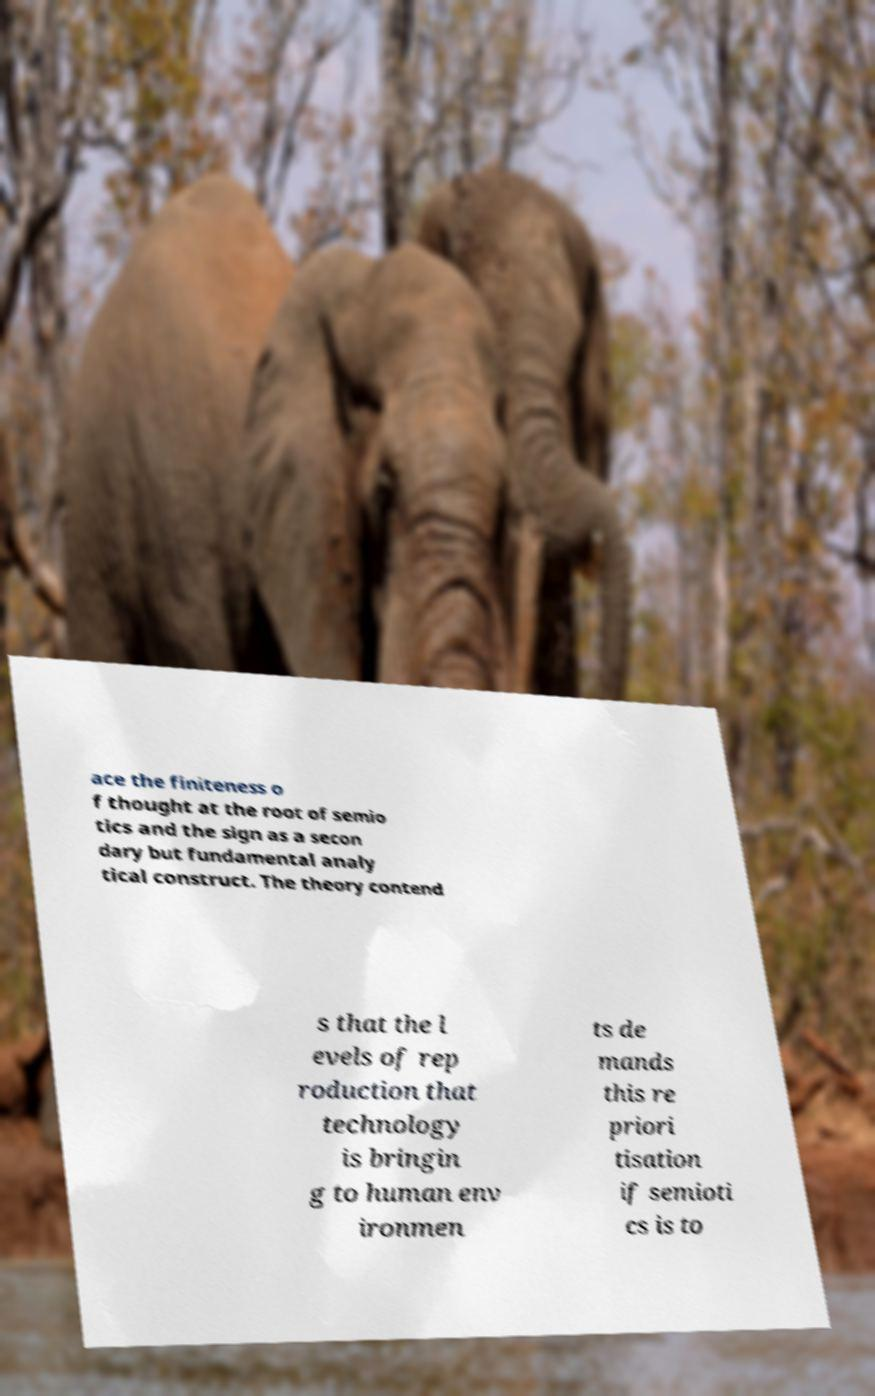For documentation purposes, I need the text within this image transcribed. Could you provide that? ace the finiteness o f thought at the root of semio tics and the sign as a secon dary but fundamental analy tical construct. The theory contend s that the l evels of rep roduction that technology is bringin g to human env ironmen ts de mands this re priori tisation if semioti cs is to 